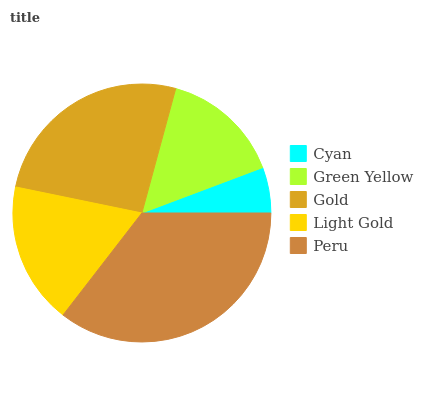Is Cyan the minimum?
Answer yes or no. Yes. Is Peru the maximum?
Answer yes or no. Yes. Is Green Yellow the minimum?
Answer yes or no. No. Is Green Yellow the maximum?
Answer yes or no. No. Is Green Yellow greater than Cyan?
Answer yes or no. Yes. Is Cyan less than Green Yellow?
Answer yes or no. Yes. Is Cyan greater than Green Yellow?
Answer yes or no. No. Is Green Yellow less than Cyan?
Answer yes or no. No. Is Light Gold the high median?
Answer yes or no. Yes. Is Light Gold the low median?
Answer yes or no. Yes. Is Cyan the high median?
Answer yes or no. No. Is Green Yellow the low median?
Answer yes or no. No. 